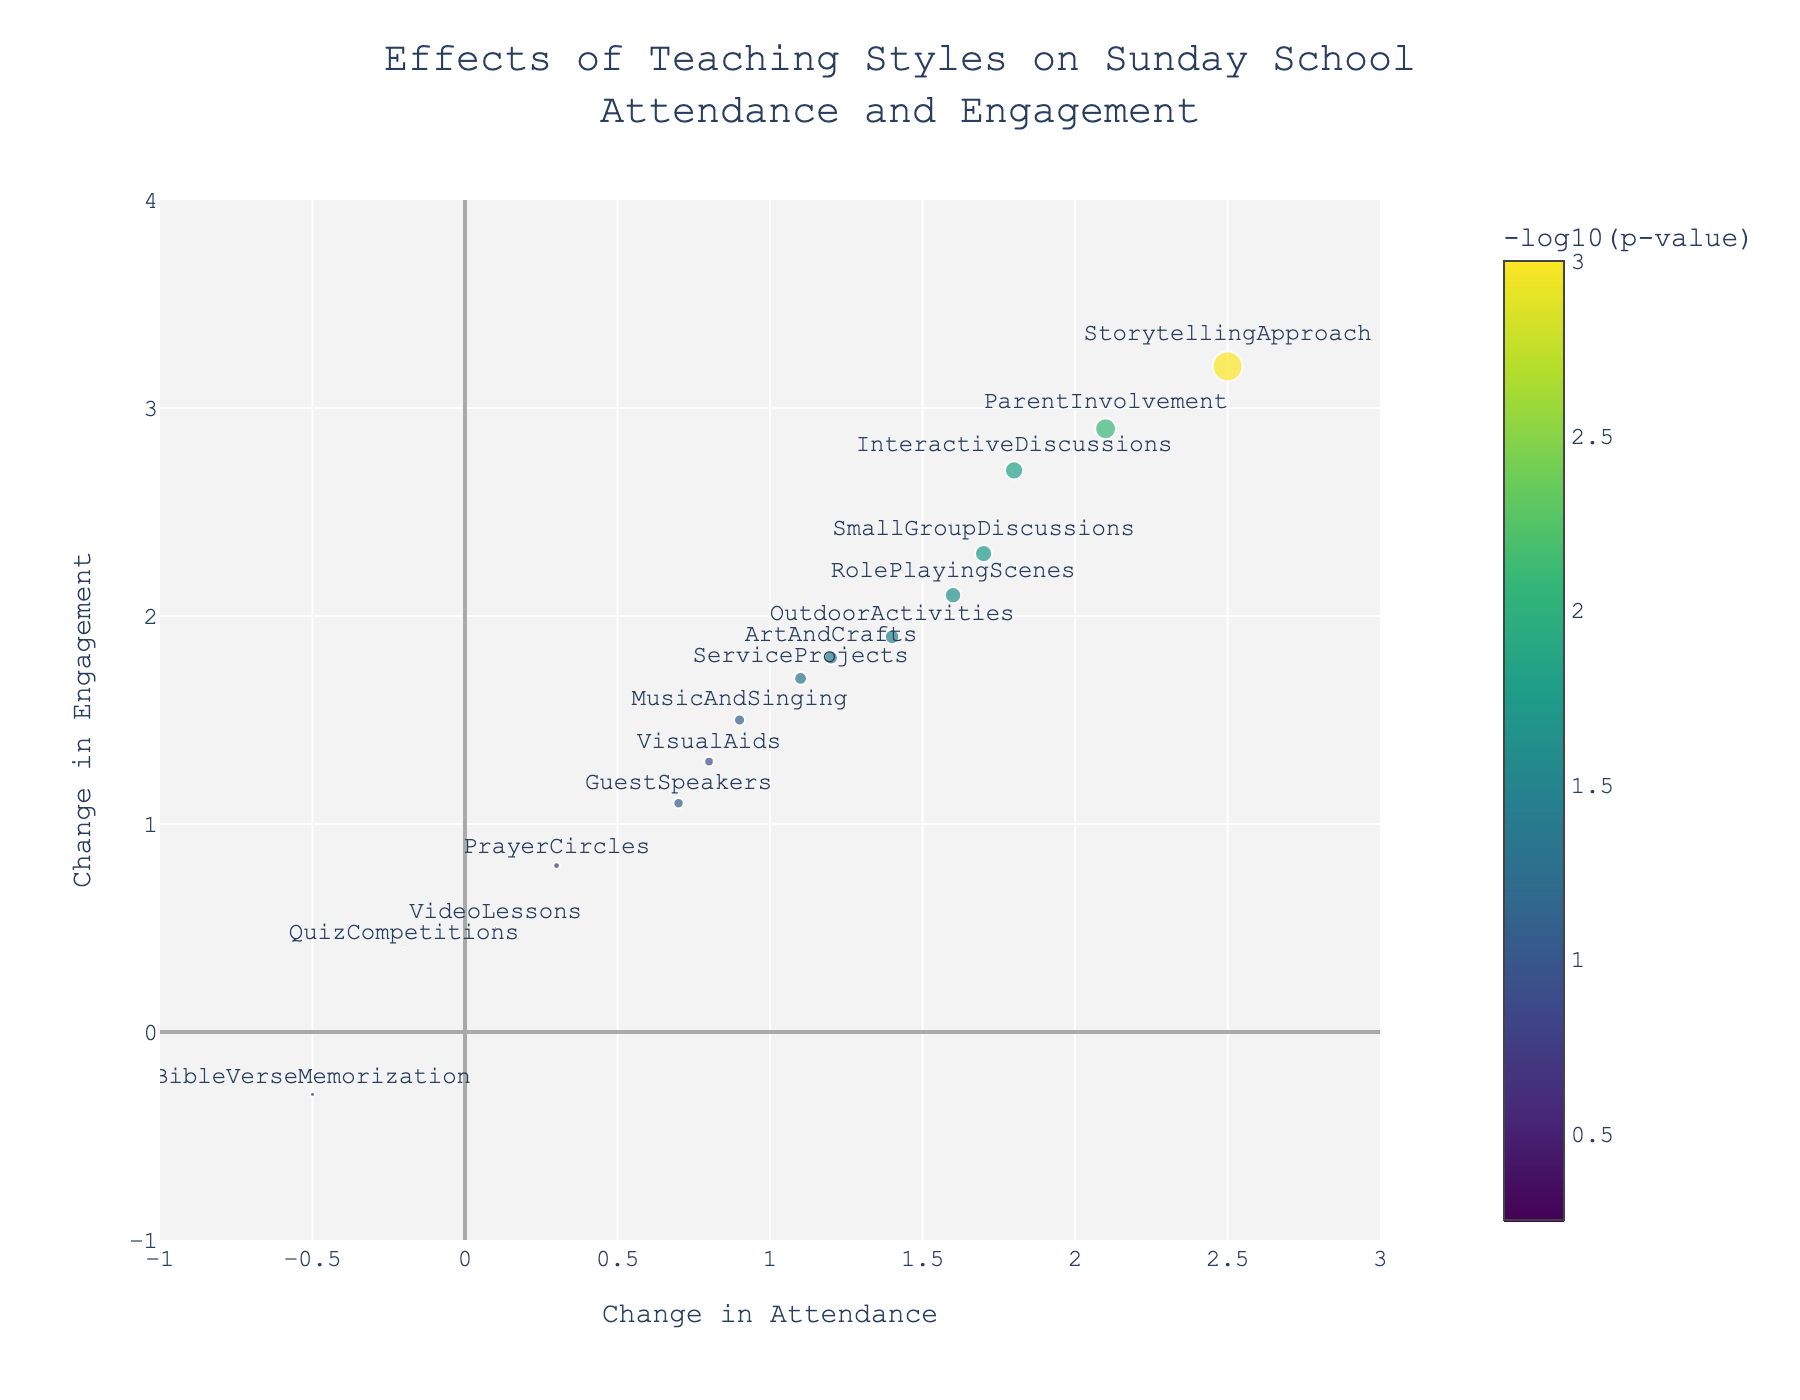What is the title of the figure? The title is usually located at the top of the plot. It summarizes what the plot represents. By looking at the top, we see "Effects of Teaching Styles on Sunday School Attendance and Engagement".
Answer: Effects of Teaching Styles on Sunday School Attendance and Engagement Which teaching style has the highest change in attendance? Check the data points along the x-axis to find the one farthest to the right. "Storytelling Approach" has the highest value at 2.5.
Answer: Storytelling Approach Which method has the lowest p-value? The data point with the largest marker size should correspond to the lowest p-value. "Storytelling Approach" has the largest marker, associated with the smallest p-value of 0.001.
Answer: Storytelling Approach How many teaching styles show a decrease in engagement? Look for data points with negative values along the y-axis. "Bible Verse Memorization" has an engagement change of -0.3.
Answer: 1 What is the color scale used for the markers? Check the color range and read the legend or color bar on the plot. The colors range from yellow to dark green with a color bar titled "-log10(p-value)" showing the scale.
Answer: Viridis Which teaching style has a decrease in both attendance and engagement? Identify points with negative x and y coordinates. "Bible Verse Memorization" has values of -0.5 and -0.3 respectively.
Answer: Bible Verse Memorization Compare the attendance change between "Interactive Discussions" and "Guest Speakers". Which one is higher? Find the data points for both. "Interactive Discussions" is at 1.8, while "Guest Speakers" is at 0.7. 1.8 > 0.7, so "Interactive Discussions" is higher.
Answer: Interactive Discussions Which teaching styles have a p-value less than 0.05? Points with larger markers typically have smaller p-values. Look at "Storytelling Approach", "Interactive Discussions", "Art And Crafts", "Role Playing Scenes", "Outdoor Activities", "Parent Involvement", "Small Group Discussions".
Answer: Storytelling Approach, Interactive Discussions, Art And Crafts, Role Playing Scenes, Outdoor Activities, Parent Involvement, Small Group Discussions What is the overall trend between attendance change and engagement change? Check the general direction in which most of the data points are distributed. There's a positive correlation as points with higher attendance also typically have higher engagement.
Answer: Positive correlation 